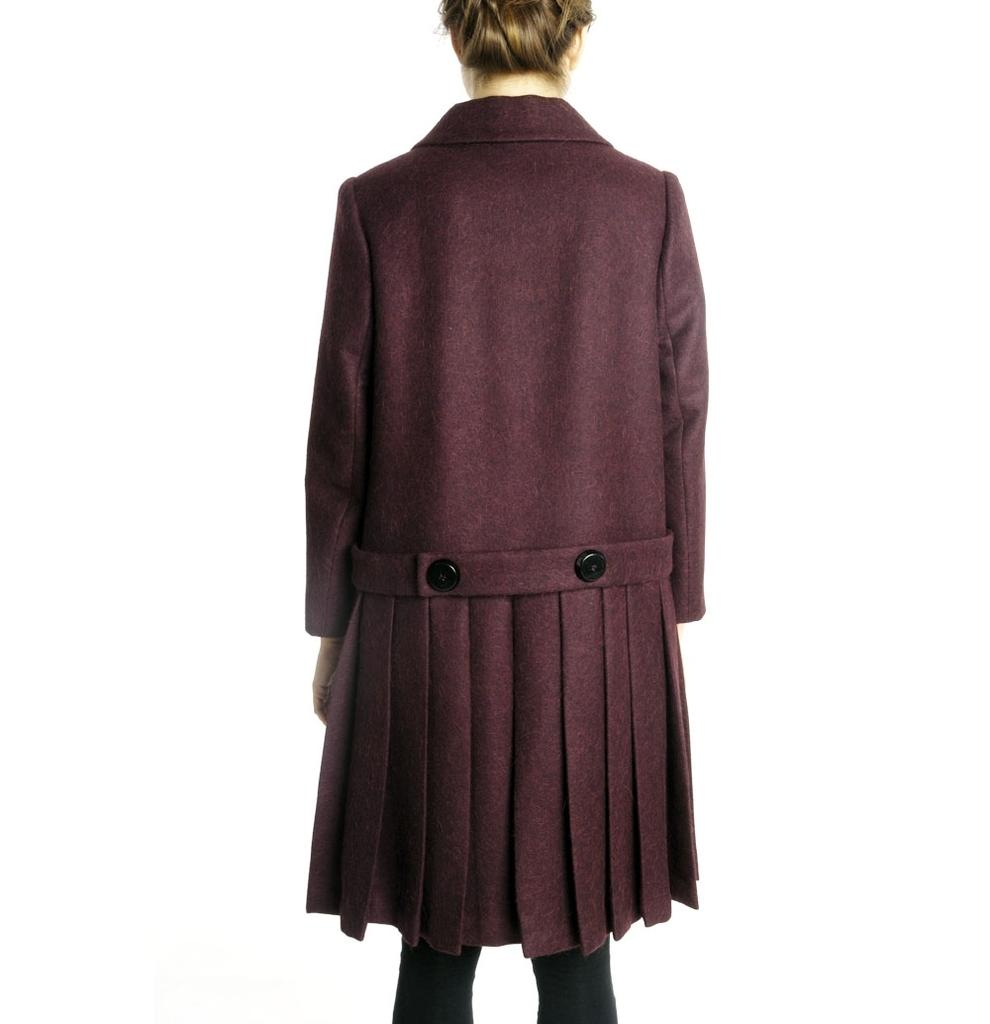Who or what is the main subject in the image? There is a person in the image. What is the person wearing? The person is wearing a dress. Can you describe the colors of the dress? The dress has maroon and black colors. What can be seen in the background of the image? The background of the image is white. How does the person in the image contribute to the harmony of the coal industry? There is no mention of the coal industry or harmony in the image, as it only features a person wearing a maroon and black dress with a white background. 